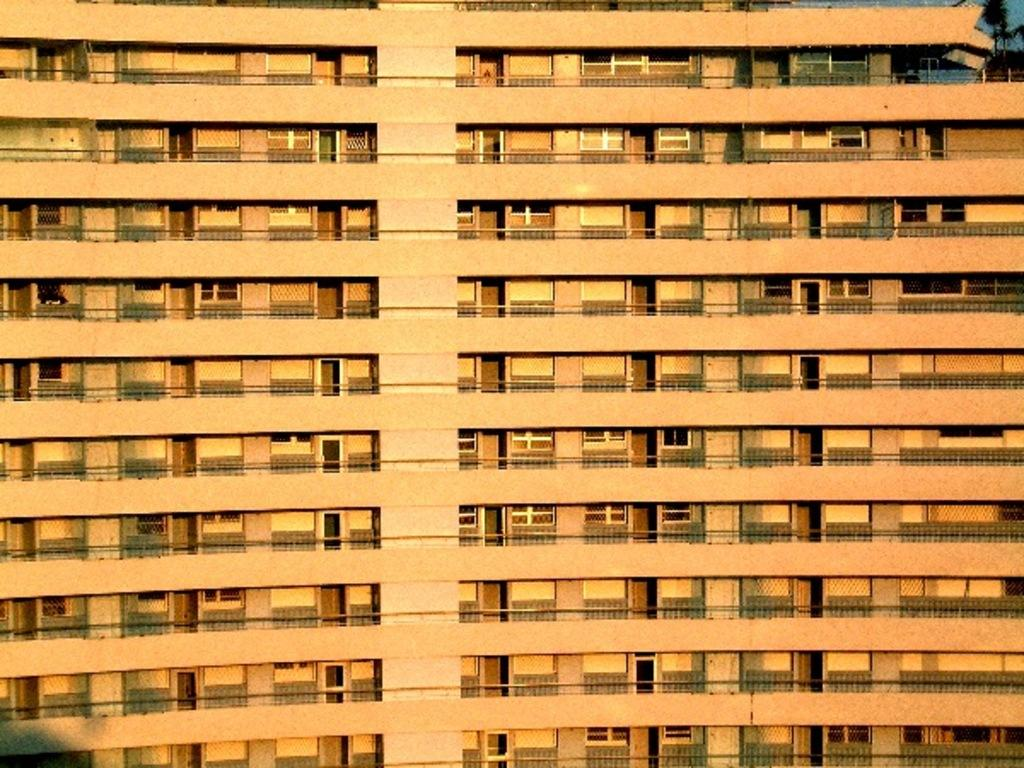What is the main structure in the image? There is a building in the image. What feature can be seen on the building? The building has windows. What type of vegetation is present at the bottom right of the image? There are plants located at the bottom right of the image. What time of day is depicted in the image, according to the hour on the building's clock? There is no clock present in the image, so it is not possible to determine the time of day. 